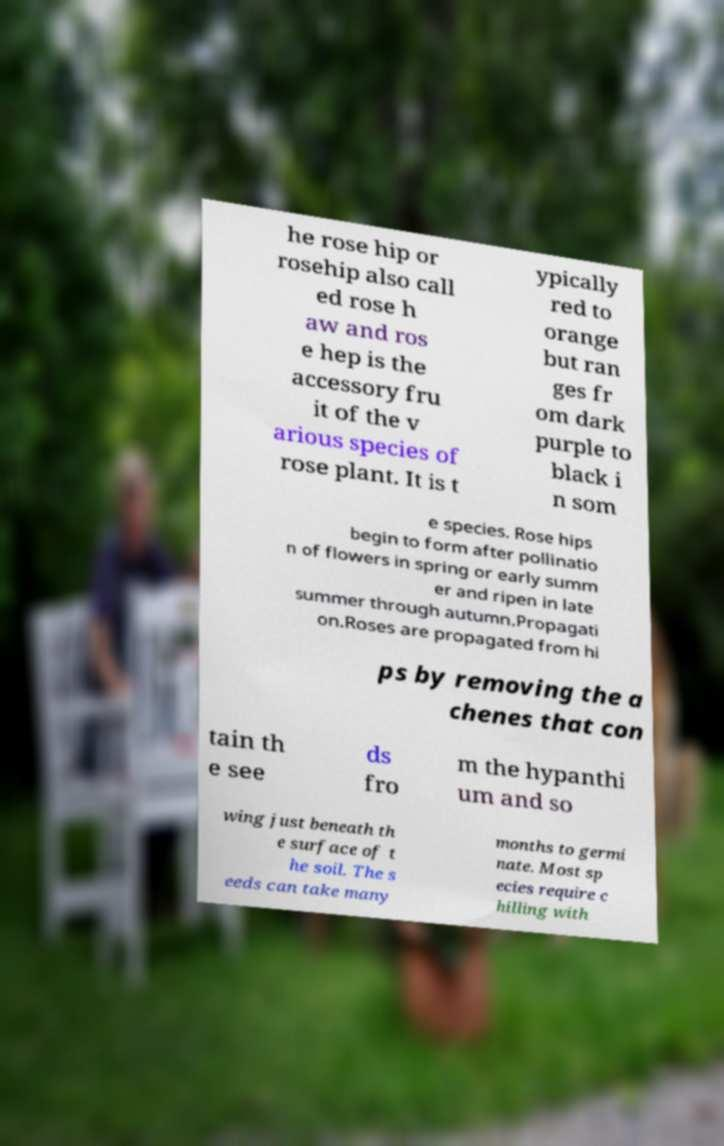What messages or text are displayed in this image? I need them in a readable, typed format. he rose hip or rosehip also call ed rose h aw and ros e hep is the accessory fru it of the v arious species of rose plant. It is t ypically red to orange but ran ges fr om dark purple to black i n som e species. Rose hips begin to form after pollinatio n of flowers in spring or early summ er and ripen in late summer through autumn.Propagati on.Roses are propagated from hi ps by removing the a chenes that con tain th e see ds fro m the hypanthi um and so wing just beneath th e surface of t he soil. The s eeds can take many months to germi nate. Most sp ecies require c hilling with 